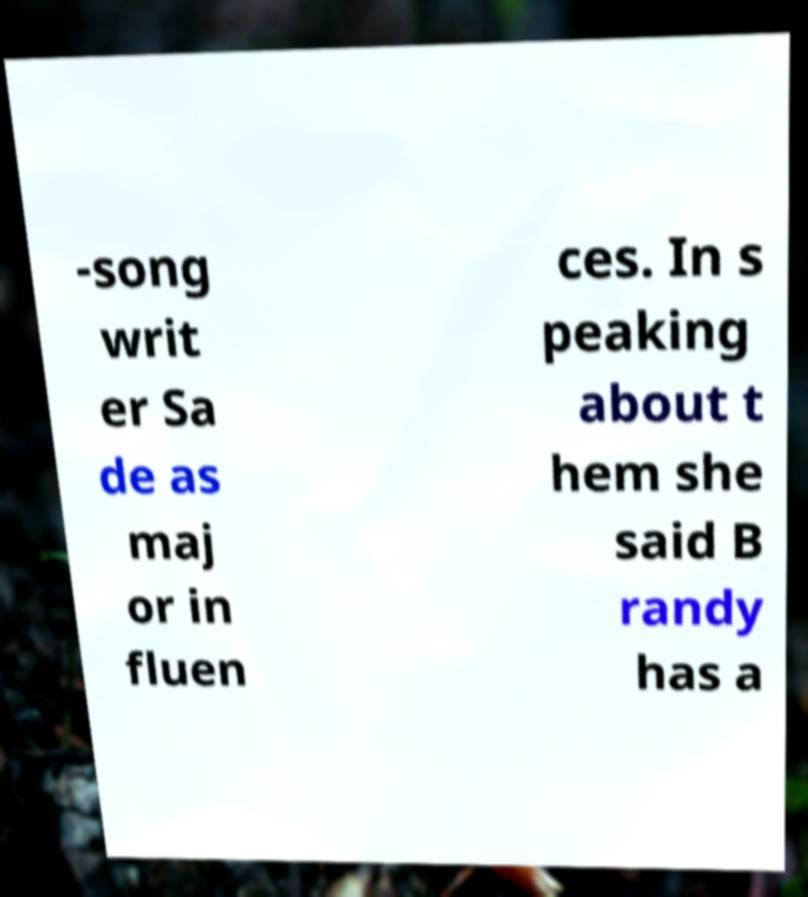Please identify and transcribe the text found in this image. -song writ er Sa de as maj or in fluen ces. In s peaking about t hem she said B randy has a 